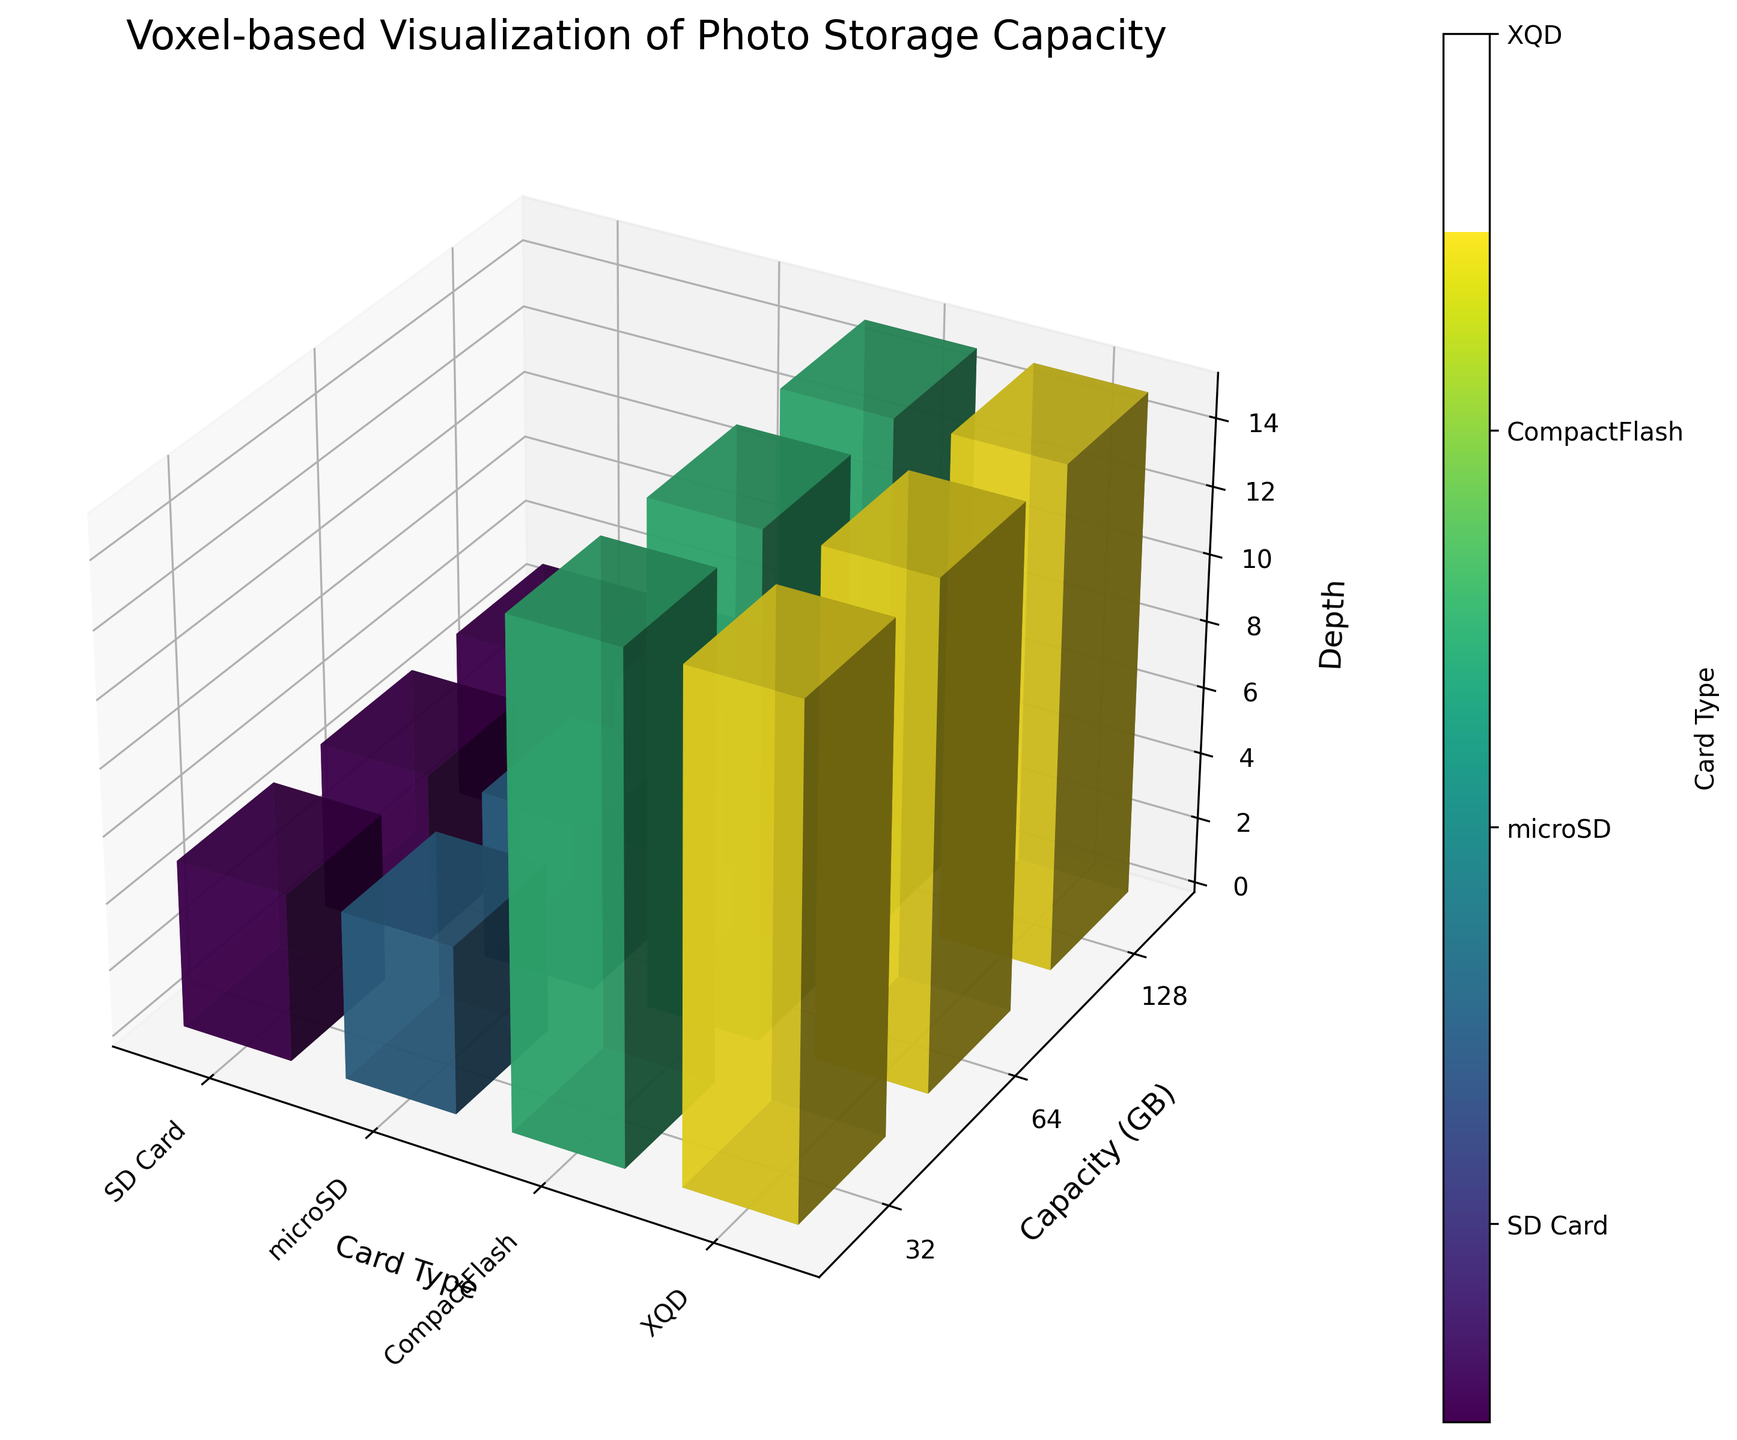What is the title of the figure? The title is usually prominently displayed and should be directly referred to. The title is located at the top of the chart.
Answer: Voxel-based Visualization of Photo Storage Capacity What units are used for the capacity on the y-axis? The y-axis is labeled with different capacities, which are given in units visible in the y-ticks.
Answer: GB Which memory card types are included in the visualization? By looking at the distinct colors and labels on the x-axis and the colorbar, we can identify the different card types included in the plot.
Answer: SD Card, microSD, CompactFlash, XQD How does the depth vary with the card type for a 64 GB card? By observing the plotted bars for each card type at the 64 GB capacity level, we can compare the depth values presented in the z-axis.
Answer: SD Card: 1, microSD: 1, CompactFlash: 3, XQD: 3 What color represents the microSD card type? The color associated with each card type can be identified from the colorbar on the side of the figure.
Answer: Greenish Which card type has the highest storage density for a 128 GB card, and what is its density? Find the 128 GB capacity level in the plot and compare the storage density values on each of the card types. Higher storage densities will be visually represented by the comparative size in the plot due to the size scaling with density.
Answer: SD Card with a storage density of 9143 How many different capacities are depicted for the SD Card type? By examining the y-ticks under the SD Card section, we can count the distinct capacities displayed.
Answer: 3 Which card type generally has the largest physical dimensions? The physical dimensions are represented by the 3D bars' width, height, and depth. By comparing these dimensions across different card types, we can determine the one with the largest general size.
Answer: CompactFlash Compare the storage densities of the highest capacity SD Card and microSD card. Which is denser, and by how much? Extract the storage densities from the plot for the 128 GB capacity for both SD Card and microSD. Subtract microSD's density from SD Card's density to find the difference.
Answer: SD Card is denser by 1385 (9143 - 7758) Which card type has the least variation in depth across different capacities? By looking at the z-axis heights for each card type across different capacities, observe which card type has the depth values that change the least.
Answer: SD Card 